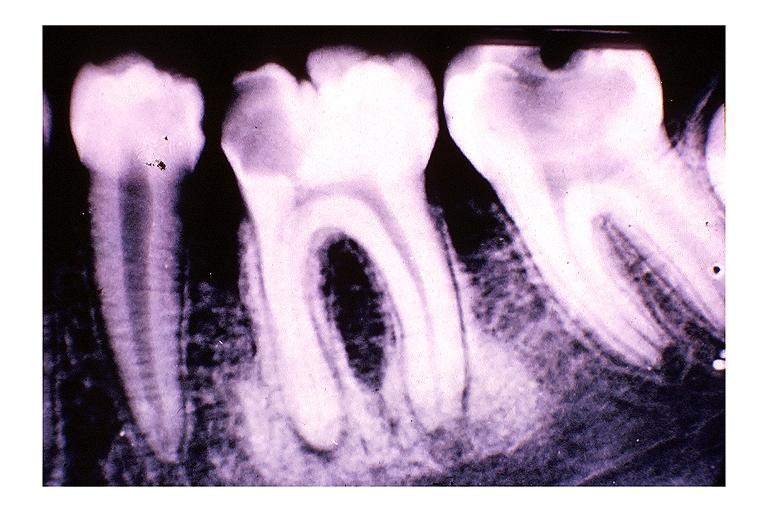s oral present?
Answer the question using a single word or phrase. Yes 